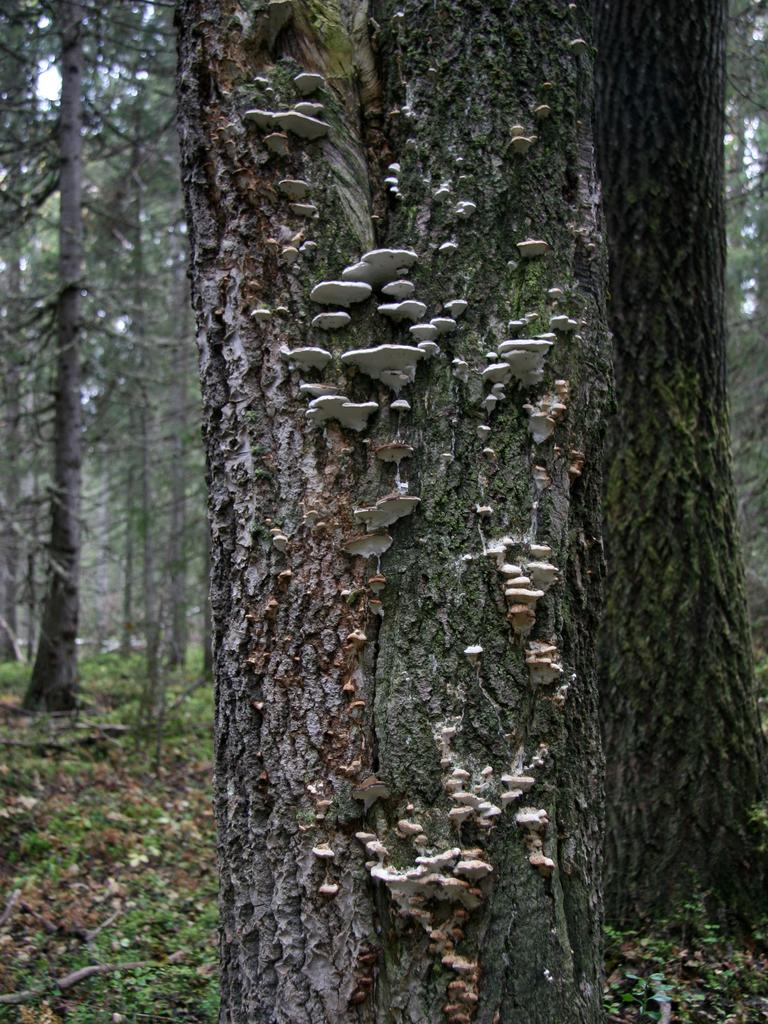What is located in the foreground of the image? There is bark of a tree in the foreground of the image. What can be seen in the background of the image? There is a group of trees and grass in the background of the image. What is visible in the sky in the image? The sky is visible in the background of the image. What type of crime is being committed in the image? There is no indication of any crime being committed in the image; it features natural elements such as tree bark, trees, grass, and the sky. 